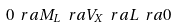<formula> <loc_0><loc_0><loc_500><loc_500>0 \ r a M _ { L } \ r a V _ { X } \ r a L \ r a 0</formula> 